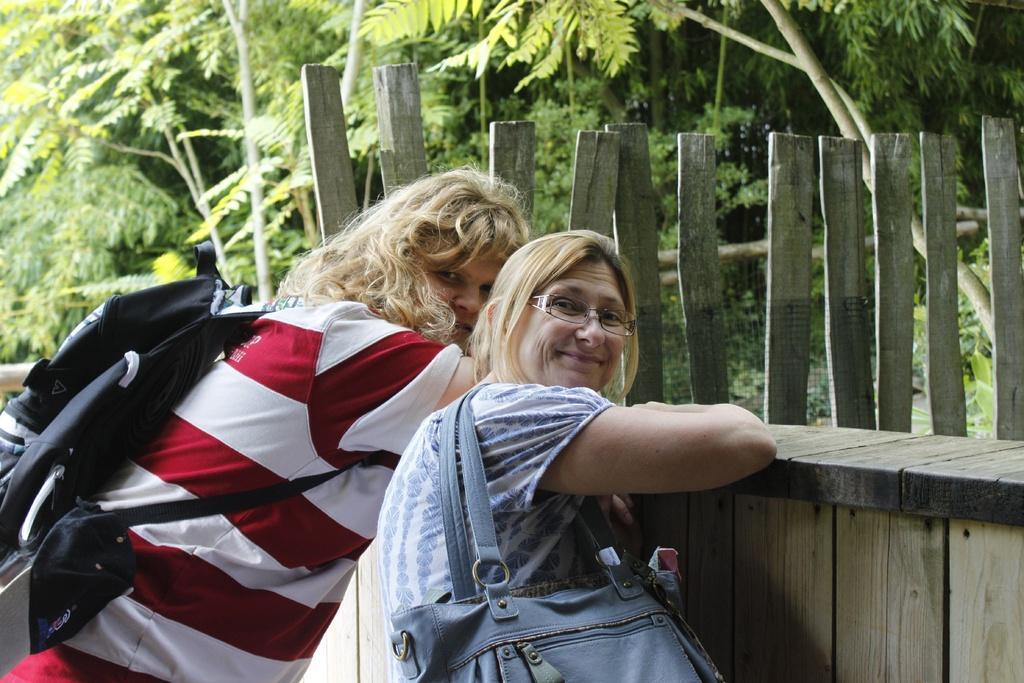Describe this image in one or two sentences. In this image there are two persons truncated towards the bottom of the image, they are wearing bags, there is a wooden wall truncated towards the right of the image, at the background of the image there are trees truncated. 